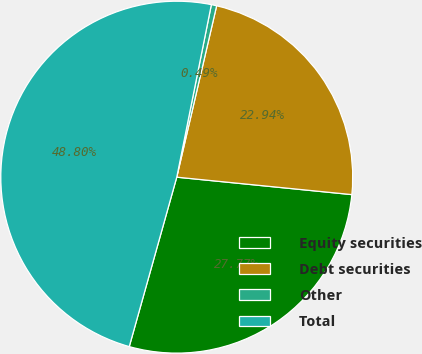<chart> <loc_0><loc_0><loc_500><loc_500><pie_chart><fcel>Equity securities<fcel>Debt securities<fcel>Other<fcel>Total<nl><fcel>27.77%<fcel>22.94%<fcel>0.49%<fcel>48.8%<nl></chart> 